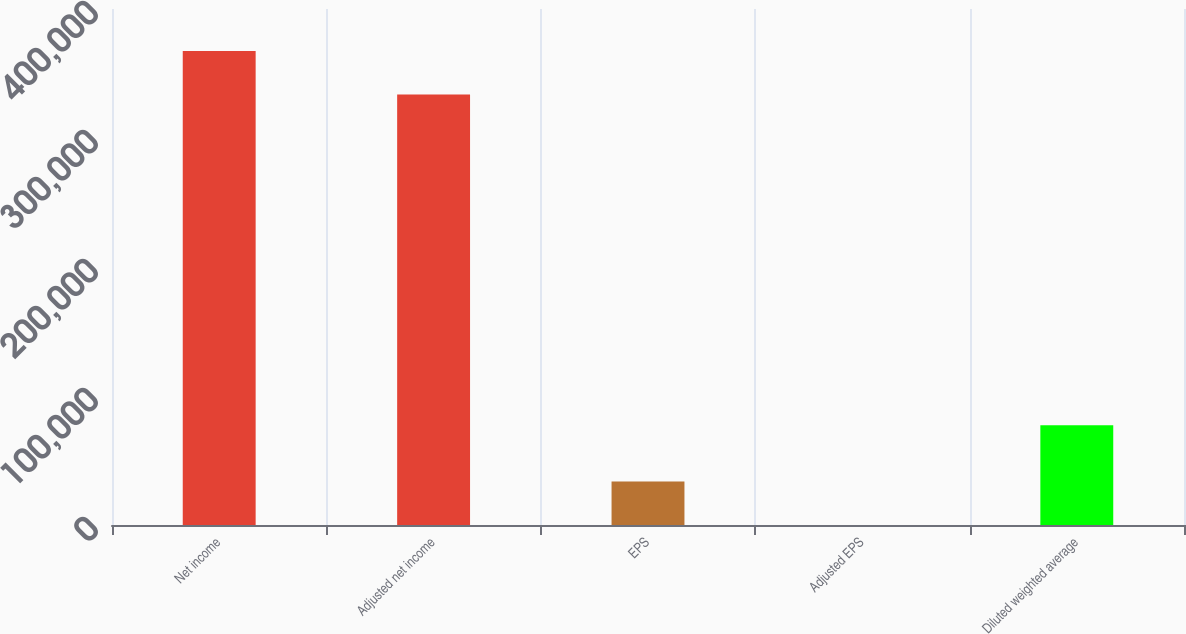Convert chart to OTSL. <chart><loc_0><loc_0><loc_500><loc_500><bar_chart><fcel>Net income<fcel>Adjusted net income<fcel>EPS<fcel>Adjusted EPS<fcel>Diluted weighted average<nl><fcel>367392<fcel>333667<fcel>33729.6<fcel>4.31<fcel>77333<nl></chart> 